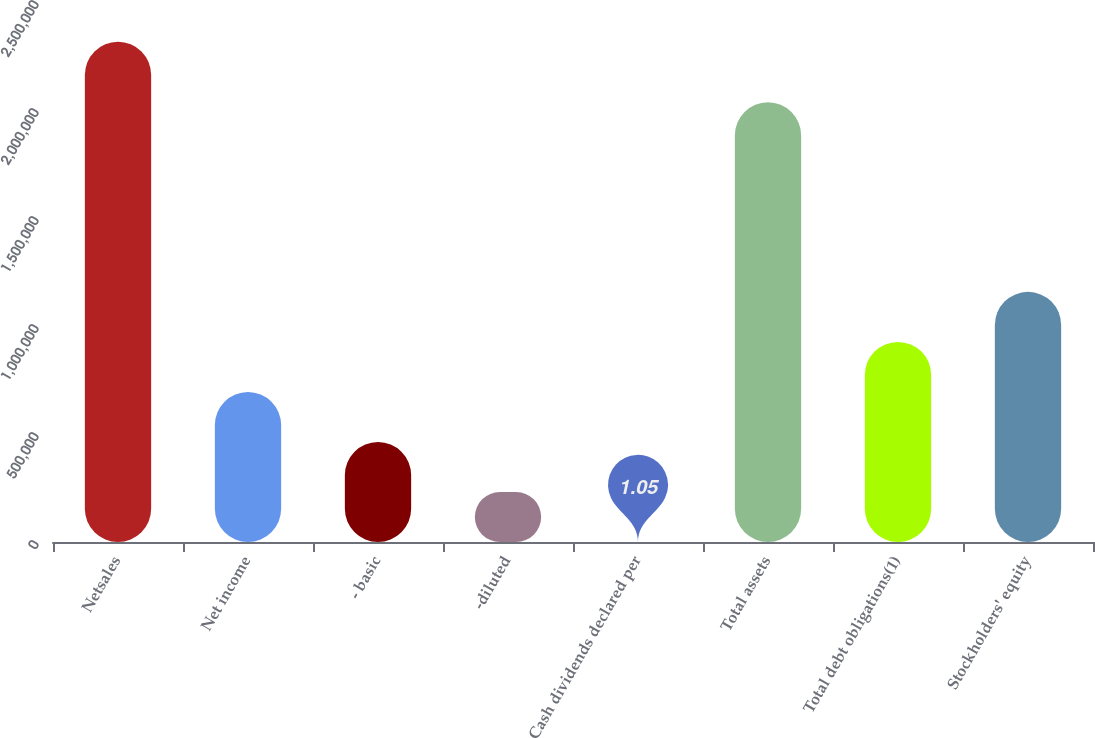<chart> <loc_0><loc_0><loc_500><loc_500><bar_chart><fcel>Netsales<fcel>Net income<fcel>- basic<fcel>-diluted<fcel>Cash dividends declared per<fcel>Total assets<fcel>Total debt obligations(1)<fcel>Stockholders' equity<nl><fcel>2.31601e+06<fcel>694803<fcel>463202<fcel>231602<fcel>1.05<fcel>2.03586e+06<fcel>926403<fcel>1.158e+06<nl></chart> 